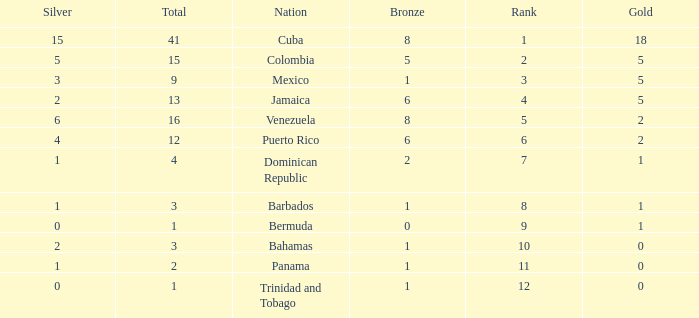Which Bronze is the highest one that has a Rank larger than 1, and a Nation of dominican republic, and a Total larger than 4? None. 